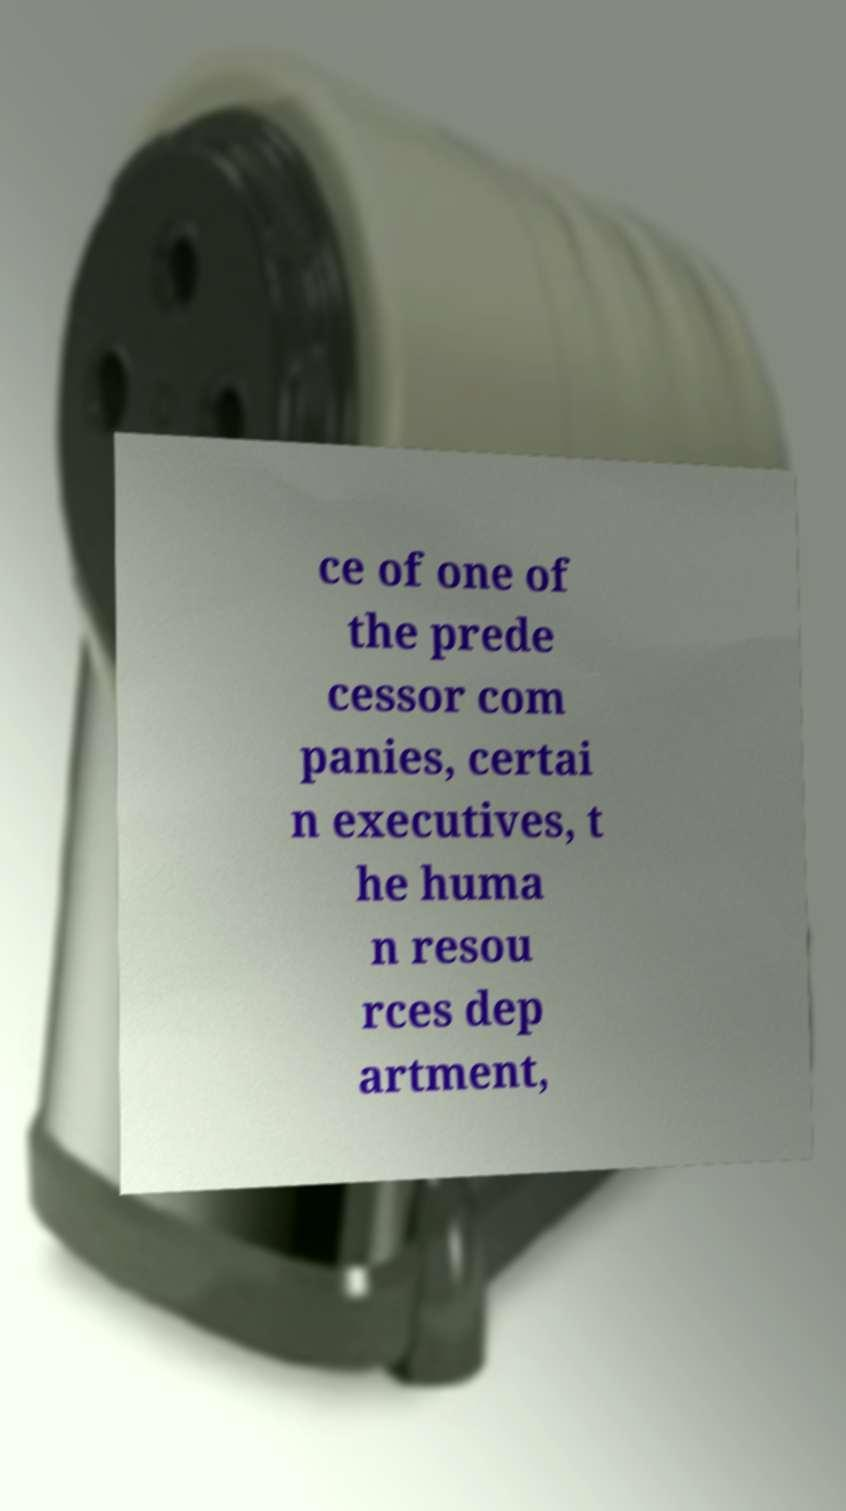I need the written content from this picture converted into text. Can you do that? ce of one of the prede cessor com panies, certai n executives, t he huma n resou rces dep artment, 